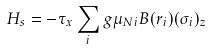<formula> <loc_0><loc_0><loc_500><loc_500>H _ { s } = - \tau _ { x } \sum _ { i } g \mu _ { N i } B ( r _ { i } ) ( \sigma _ { i } ) _ { z }</formula> 